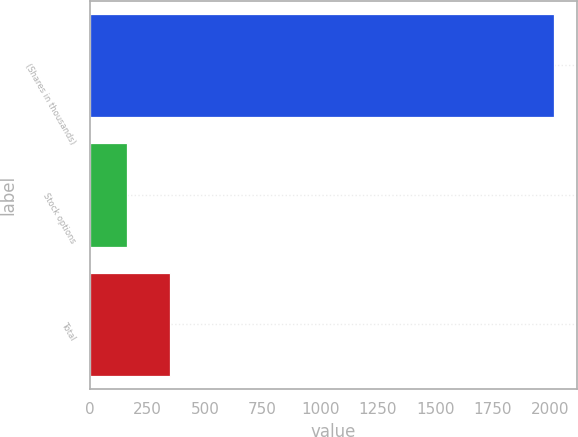Convert chart to OTSL. <chart><loc_0><loc_0><loc_500><loc_500><bar_chart><fcel>(Shares in thousands)<fcel>Stock options<fcel>Total<nl><fcel>2014<fcel>161<fcel>346.3<nl></chart> 